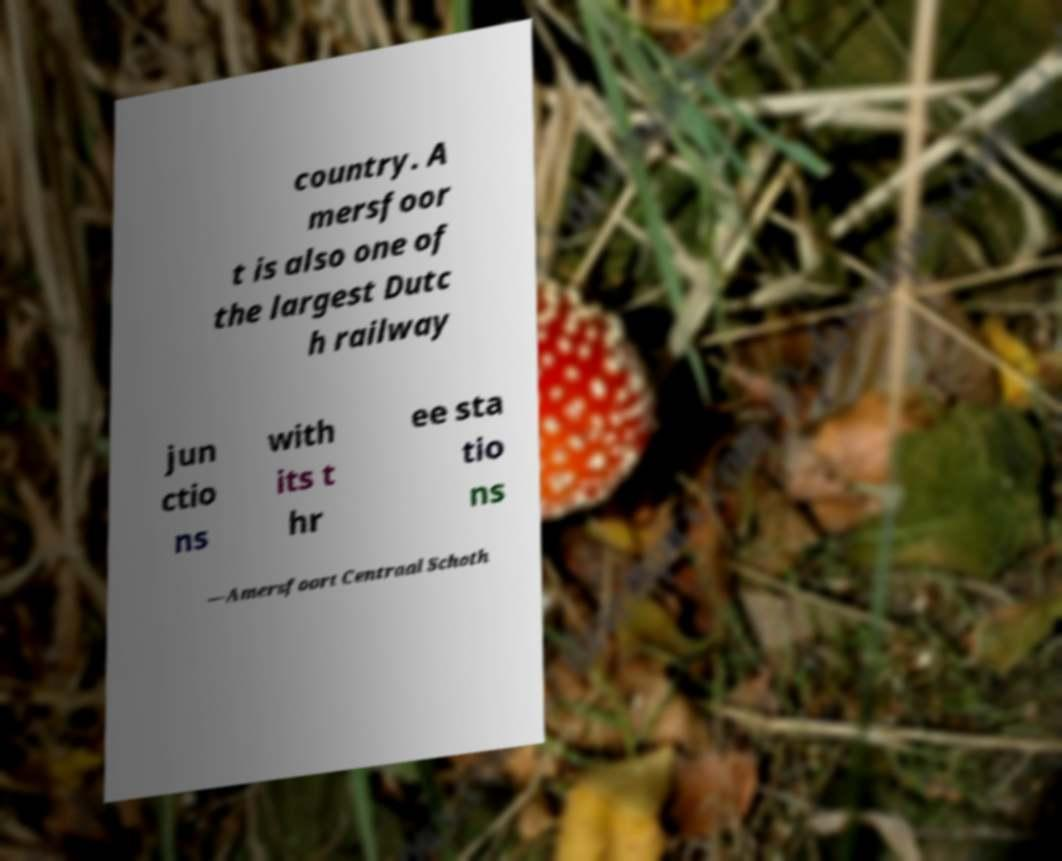Please identify and transcribe the text found in this image. country. A mersfoor t is also one of the largest Dutc h railway jun ctio ns with its t hr ee sta tio ns —Amersfoort Centraal Schoth 